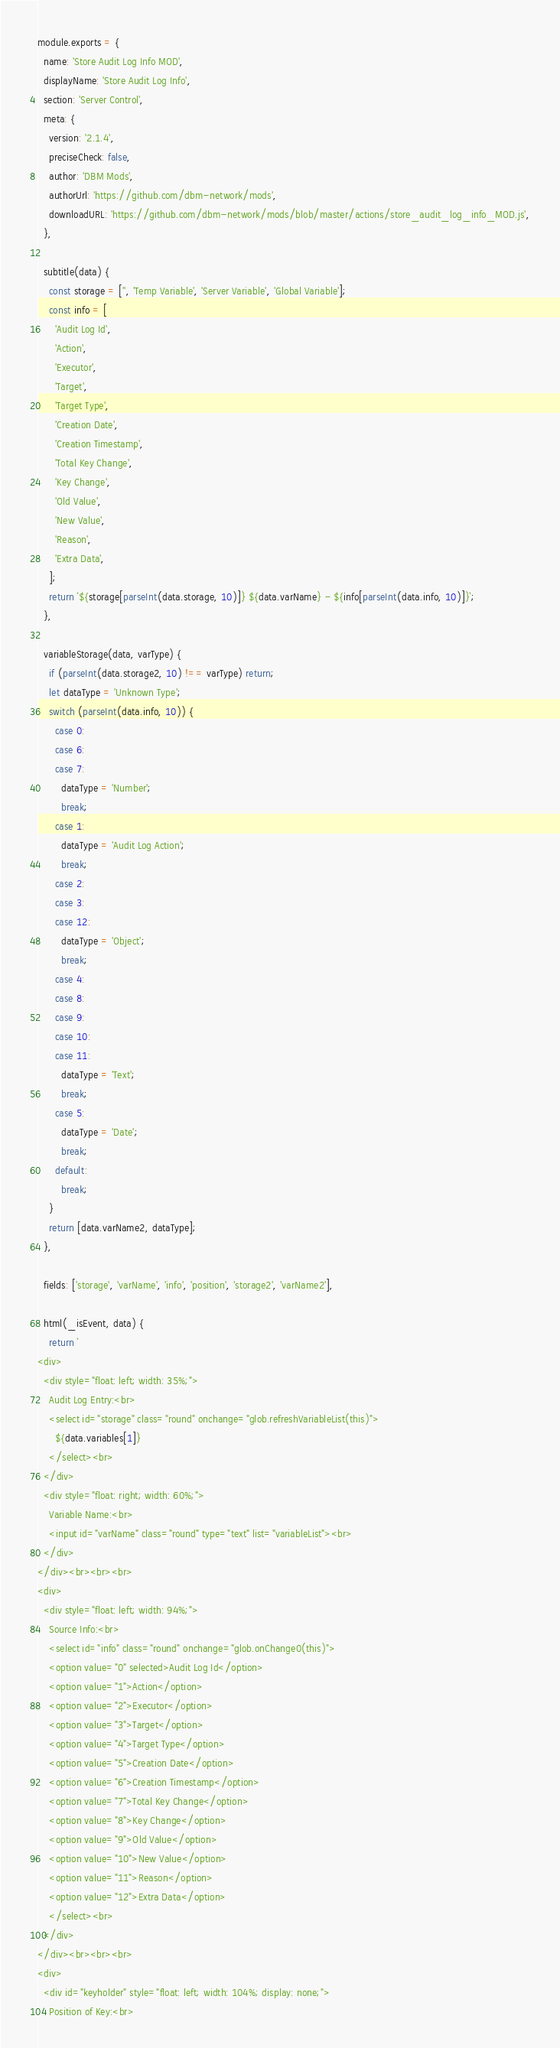Convert code to text. <code><loc_0><loc_0><loc_500><loc_500><_JavaScript_>module.exports = {
  name: 'Store Audit Log Info MOD',
  displayName: 'Store Audit Log Info',
  section: 'Server Control',
  meta: {
    version: '2.1.4',
    preciseCheck: false,
    author: 'DBM Mods',
    authorUrl: 'https://github.com/dbm-network/mods',
    downloadURL: 'https://github.com/dbm-network/mods/blob/master/actions/store_audit_log_info_MOD.js',
  },

  subtitle(data) {
    const storage = ['', 'Temp Variable', 'Server Variable', 'Global Variable'];
    const info = [
      'Audit Log Id',
      'Action',
      'Executor',
      'Target',
      'Target Type',
      'Creation Date',
      'Creation Timestamp',
      'Total Key Change',
      'Key Change',
      'Old Value',
      'New Value',
      'Reason',
      'Extra Data',
    ];
    return `${storage[parseInt(data.storage, 10)]} ${data.varName} - ${info[parseInt(data.info, 10)]}`;
  },

  variableStorage(data, varType) {
    if (parseInt(data.storage2, 10) !== varType) return;
    let dataType = 'Unknown Type';
    switch (parseInt(data.info, 10)) {
      case 0:
      case 6:
      case 7:
        dataType = 'Number';
        break;
      case 1:
        dataType = 'Audit Log Action';
        break;
      case 2:
      case 3:
      case 12:
        dataType = 'Object';
        break;
      case 4:
      case 8:
      case 9:
      case 10:
      case 11:
        dataType = 'Text';
        break;
      case 5:
        dataType = 'Date';
        break;
      default:
        break;
    }
    return [data.varName2, dataType];
  },

  fields: ['storage', 'varName', 'info', 'position', 'storage2', 'varName2'],

  html(_isEvent, data) {
    return `
<div>
  <div style="float: left; width: 35%;">
    Audit Log Entry:<br>
    <select id="storage" class="round" onchange="glob.refreshVariableList(this)">
      ${data.variables[1]}
    </select><br>
  </div>
  <div style="float: right; width: 60%;">
    Variable Name:<br>
    <input id="varName" class="round" type="text" list="variableList"><br>
  </div>
</div><br><br><br>
<div>
  <div style="float: left; width: 94%;">
    Source Info:<br>
    <select id="info" class="round" onchange="glob.onChange0(this)">
    <option value="0" selected>Audit Log Id</option>
    <option value="1">Action</option>
    <option value="2">Executor</option>
    <option value="3">Target</option>
    <option value="4">Target Type</option>
    <option value="5">Creation Date</option>
    <option value="6">Creation Timestamp</option>
    <option value="7">Total Key Change</option>
    <option value="8">Key Change</option>
    <option value="9">Old Value</option>
    <option value="10">New Value</option>
    <option value="11">Reason</option>
    <option value="12">Extra Data</option>
    </select><br>
  </div>
</div><br><br><br>
<div>
  <div id="keyholder" style="float: left; width: 104%; display: none;">
    Position of Key:<br></code> 